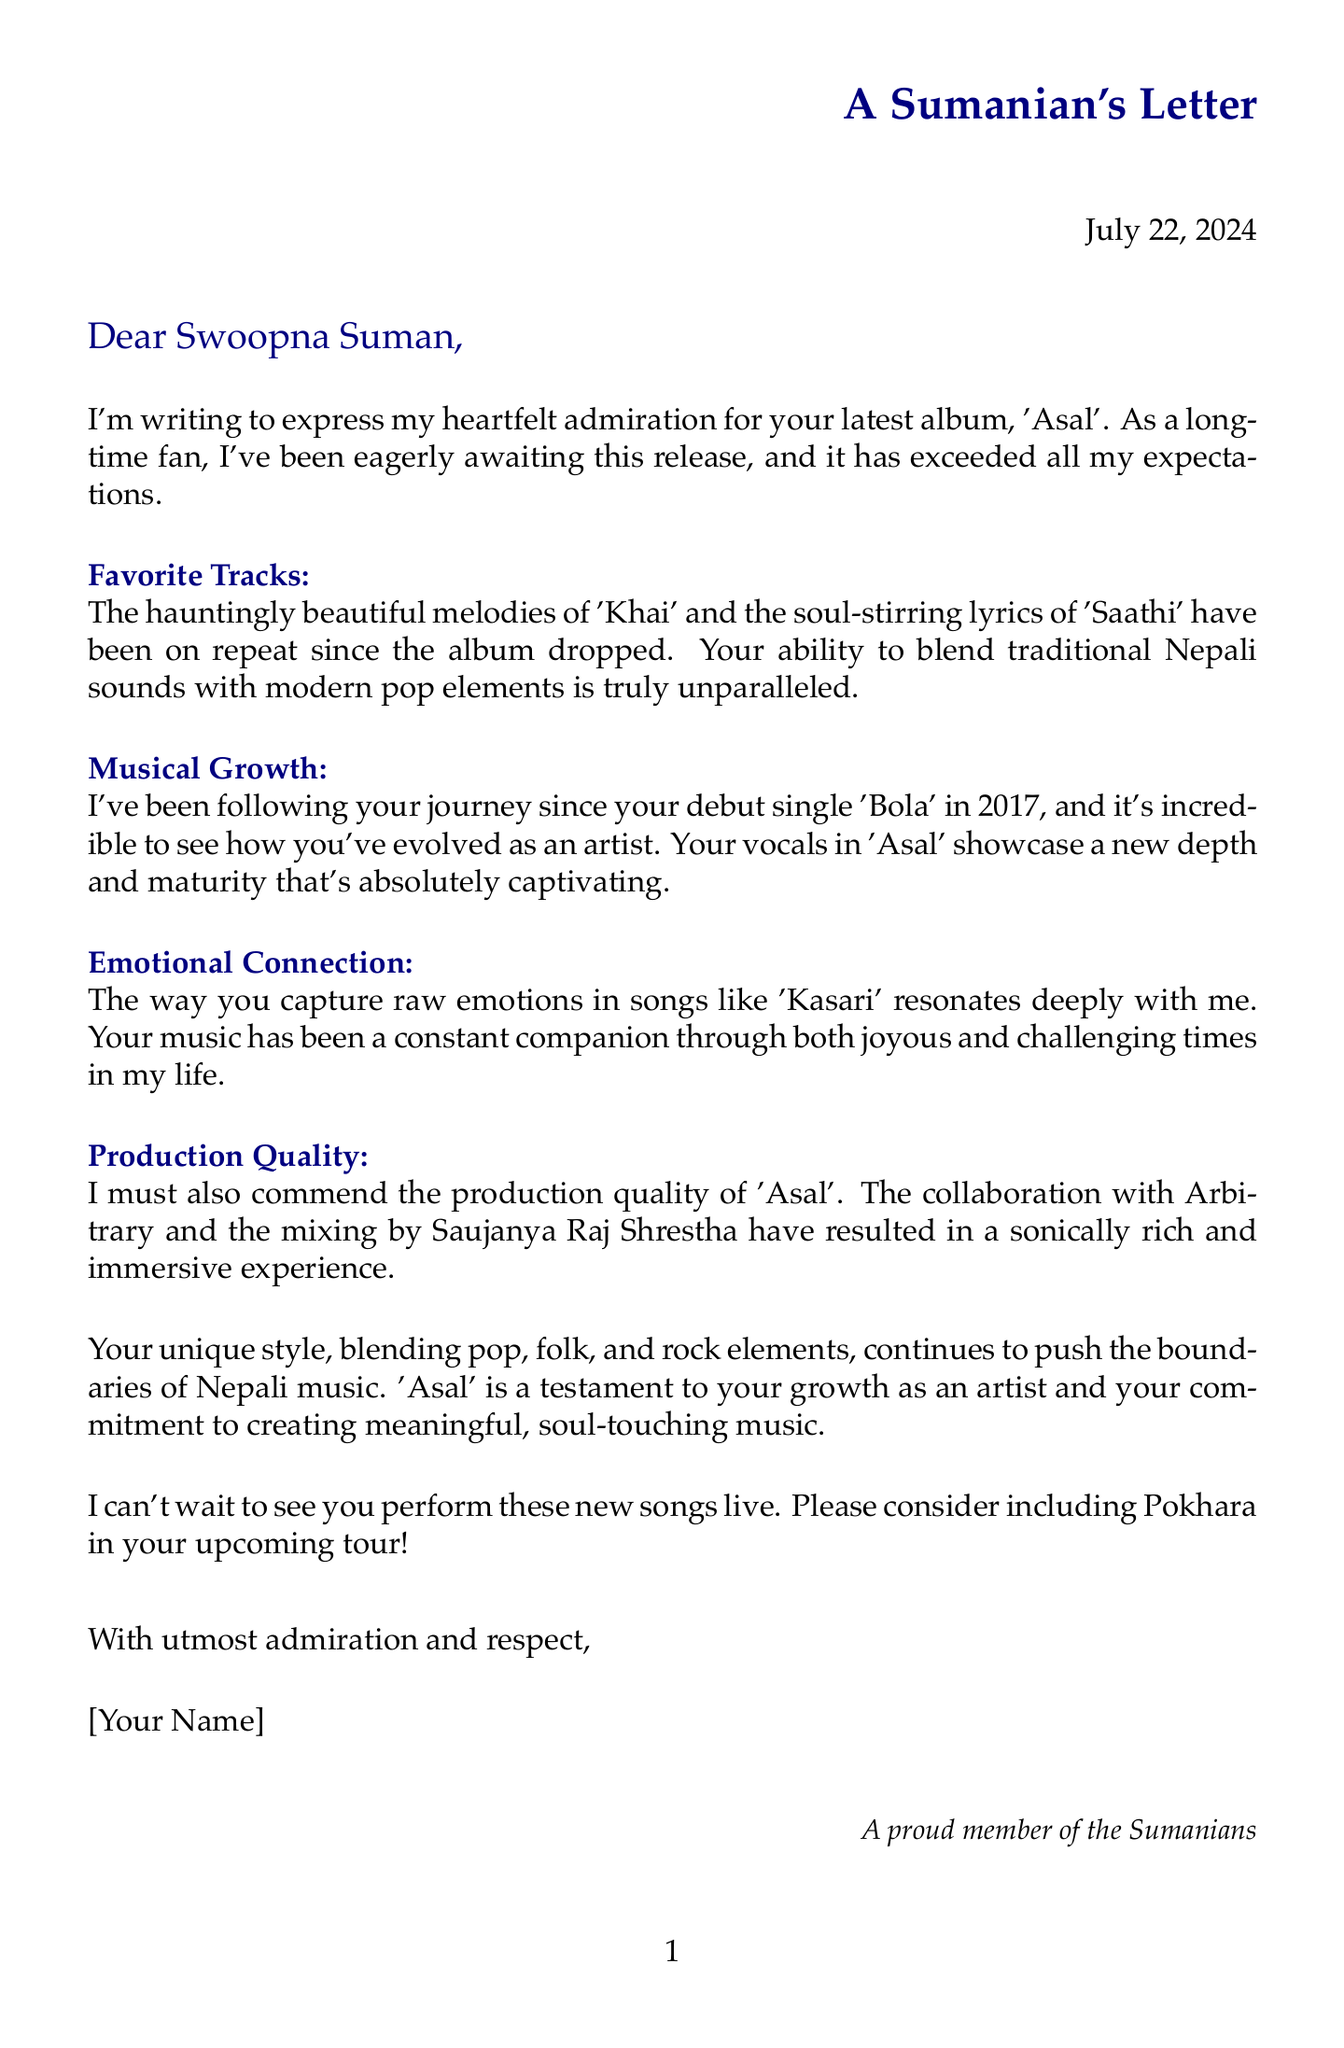What is the name of the album discussed in the letter? The album discussed in the letter is 'Asal', which is the main subject of admiration in the document.
Answer: 'Asal' Who is the letter addressed to? The letter is addressed to Swoopna Suman, the artist being admired by the fan.
Answer: Swoopna Suman What year was the album 'Asal' released? The release year of the album 'Asal' is mentioned in the introduction section of the letter.
Answer: 2023 How many tracks are there in the album 'Asal'? The document states that 'Asal' contains a total of eight tracks, which is specific information given in the additional details.
Answer: 8 Which two songs from the album are highlighted as favorites? The letter specifically highlights 'Khai' and 'Saathi' as favorite tracks, indicating the fan's admiration for these specific songs.
Answer: 'Khai' and 'Saathi' What is the name of the fan club mentioned in the letter? The fan club name mentioned in the letter signifies the fan's pride and connection to the fandom of Swoopna Suman.
Answer: Sumanians What is the primary emotion expressed by the fan towards the album in the conclusion? The conclusion indicates a strong admiration and respect for Swoopna Suman's music, showcasing the fan's emotional connection.
Answer: Admiration Which city does the fan hope Swoopna Suman will include in his upcoming tour? The fan expresses a wish for Pokhara to be included in Swoopna Suman's upcoming tour, emphasizing their desire to see him live.
Answer: Pokhara What type of music style does 'Asal' represent? The letter mentions that the musical style of 'Asal' is a fusion, specifically casting a light on its genre blending.
Answer: Nepali Pop-Folk fusion 